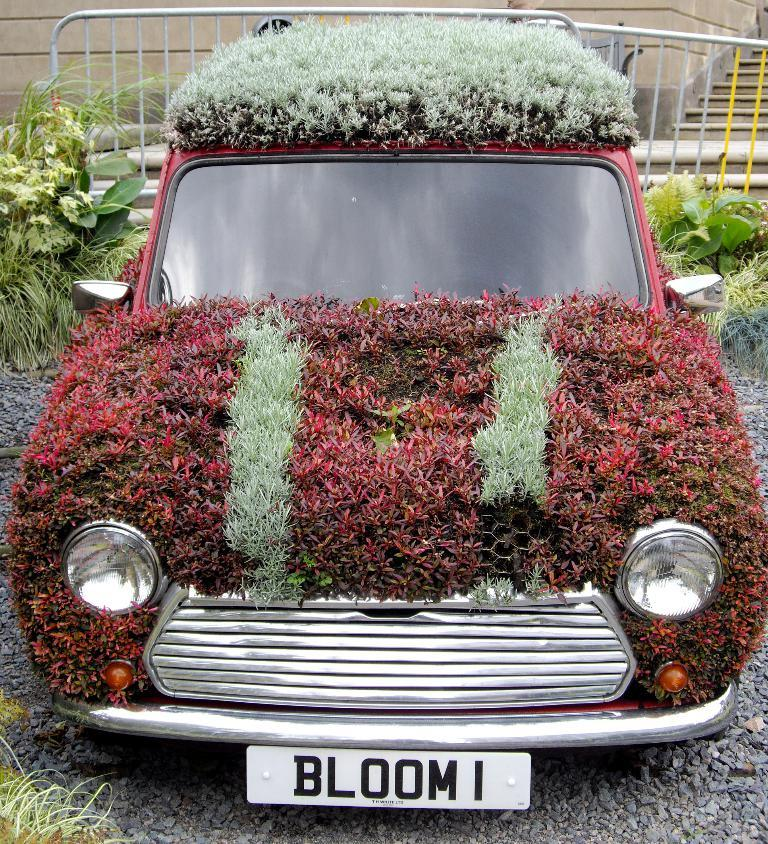What is unusual about the car in the image? The car is covered with grass in the image. What type of vegetation can be seen in the image? There are plants in the image. What architectural feature is present in the image? There is a fence in the image. Are there any steps visible in the image? Yes, there are stairs in the image. What structure can be seen in the background of the image? There is a wall in the image. How much grain is being delivered to the car in the image? There is no grain or delivery mentioned in the image; the car is simply covered with grass. 